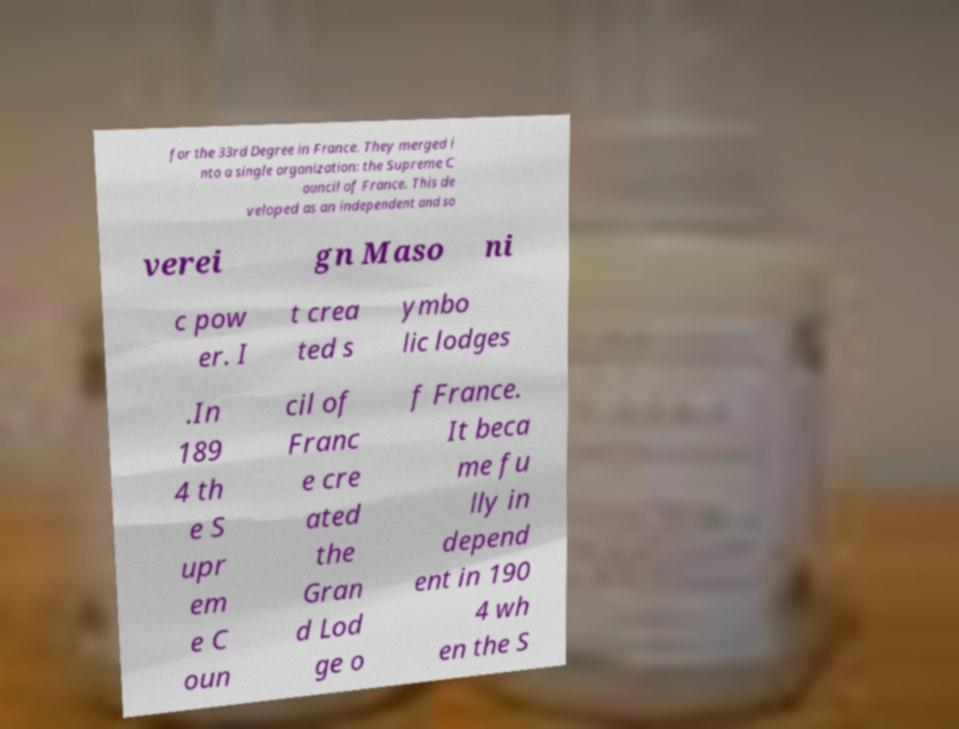There's text embedded in this image that I need extracted. Can you transcribe it verbatim? for the 33rd Degree in France. They merged i nto a single organization: the Supreme C ouncil of France. This de veloped as an independent and so verei gn Maso ni c pow er. I t crea ted s ymbo lic lodges .In 189 4 th e S upr em e C oun cil of Franc e cre ated the Gran d Lod ge o f France. It beca me fu lly in depend ent in 190 4 wh en the S 